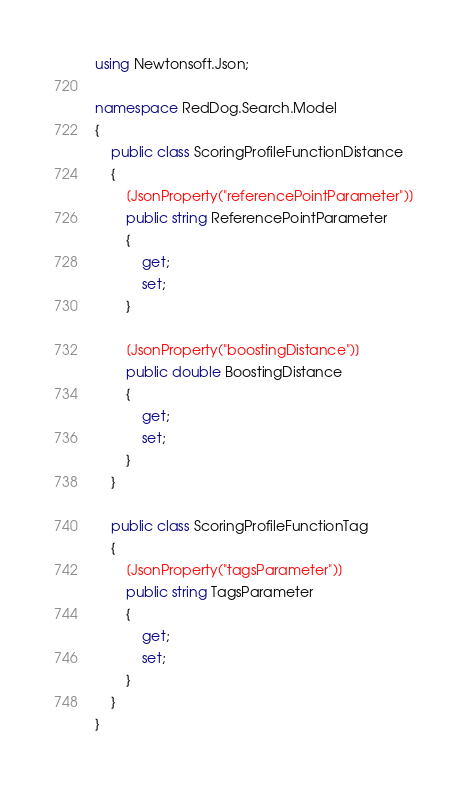<code> <loc_0><loc_0><loc_500><loc_500><_C#_>using Newtonsoft.Json;

namespace RedDog.Search.Model
{
    public class ScoringProfileFunctionDistance
    {
        [JsonProperty("referencePointParameter")]
        public string ReferencePointParameter
        {
            get;
            set;
        }

        [JsonProperty("boostingDistance")]
        public double BoostingDistance
        {
            get;
            set;
        }
    }
    
    public class ScoringProfileFunctionTag
    {
        [JsonProperty("tagsParameter")]
        public string TagsParameter
        {
            get;
            set;
        }
    }
}</code> 